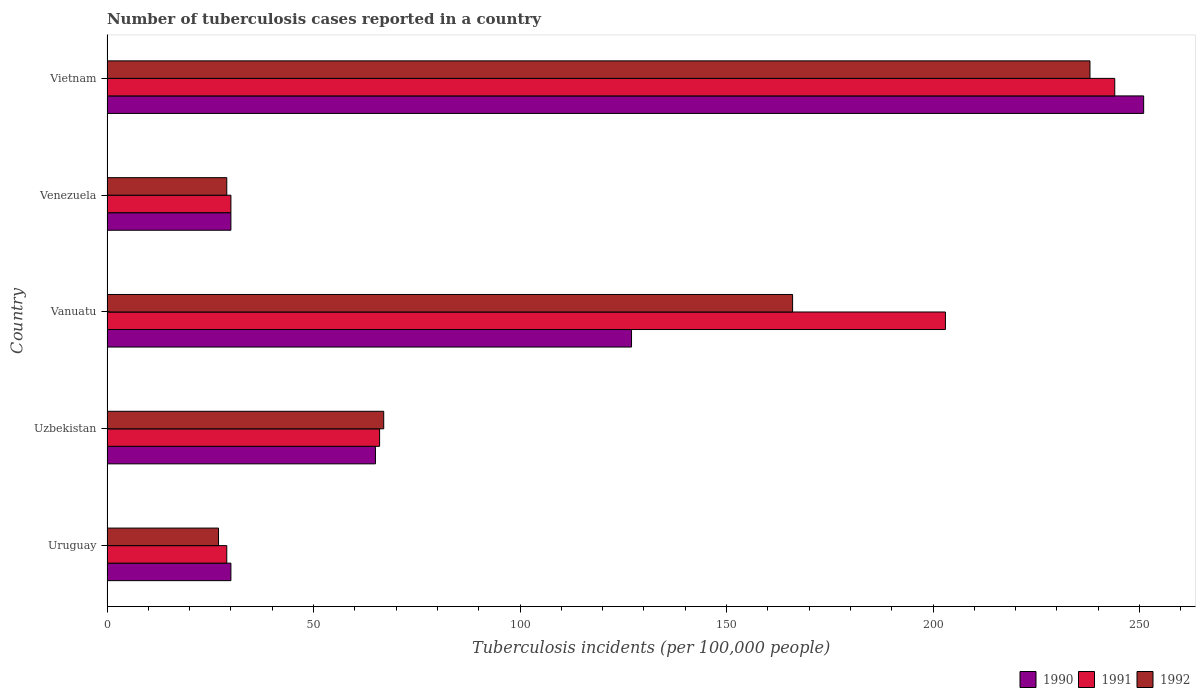How many different coloured bars are there?
Keep it short and to the point. 3. How many groups of bars are there?
Keep it short and to the point. 5. Are the number of bars per tick equal to the number of legend labels?
Offer a very short reply. Yes. Are the number of bars on each tick of the Y-axis equal?
Offer a terse response. Yes. How many bars are there on the 1st tick from the bottom?
Provide a succinct answer. 3. What is the label of the 5th group of bars from the top?
Your response must be concise. Uruguay. What is the number of tuberculosis cases reported in in 1992 in Vietnam?
Offer a terse response. 238. Across all countries, what is the maximum number of tuberculosis cases reported in in 1990?
Make the answer very short. 251. Across all countries, what is the minimum number of tuberculosis cases reported in in 1991?
Offer a terse response. 29. In which country was the number of tuberculosis cases reported in in 1990 maximum?
Give a very brief answer. Vietnam. In which country was the number of tuberculosis cases reported in in 1991 minimum?
Your answer should be very brief. Uruguay. What is the total number of tuberculosis cases reported in in 1991 in the graph?
Provide a succinct answer. 572. What is the difference between the number of tuberculosis cases reported in in 1991 in Uzbekistan and that in Vietnam?
Your answer should be compact. -178. What is the difference between the number of tuberculosis cases reported in in 1991 in Venezuela and the number of tuberculosis cases reported in in 1990 in Vanuatu?
Offer a very short reply. -97. What is the average number of tuberculosis cases reported in in 1991 per country?
Your response must be concise. 114.4. What is the ratio of the number of tuberculosis cases reported in in 1992 in Uzbekistan to that in Vanuatu?
Your answer should be very brief. 0.4. Is the number of tuberculosis cases reported in in 1992 in Uzbekistan less than that in Vietnam?
Offer a terse response. Yes. What is the difference between the highest and the second highest number of tuberculosis cases reported in in 1992?
Offer a terse response. 72. What is the difference between the highest and the lowest number of tuberculosis cases reported in in 1991?
Your response must be concise. 215. What does the 1st bar from the top in Vanuatu represents?
Ensure brevity in your answer.  1992. What does the 2nd bar from the bottom in Vietnam represents?
Ensure brevity in your answer.  1991. How many bars are there?
Ensure brevity in your answer.  15. Are all the bars in the graph horizontal?
Make the answer very short. Yes. What is the difference between two consecutive major ticks on the X-axis?
Provide a succinct answer. 50. Does the graph contain grids?
Provide a short and direct response. No. How many legend labels are there?
Keep it short and to the point. 3. How are the legend labels stacked?
Your answer should be very brief. Horizontal. What is the title of the graph?
Your answer should be compact. Number of tuberculosis cases reported in a country. Does "1999" appear as one of the legend labels in the graph?
Ensure brevity in your answer.  No. What is the label or title of the X-axis?
Your answer should be compact. Tuberculosis incidents (per 100,0 people). What is the label or title of the Y-axis?
Provide a succinct answer. Country. What is the Tuberculosis incidents (per 100,000 people) of 1991 in Uruguay?
Your answer should be very brief. 29. What is the Tuberculosis incidents (per 100,000 people) of 1992 in Uruguay?
Provide a succinct answer. 27. What is the Tuberculosis incidents (per 100,000 people) in 1991 in Uzbekistan?
Offer a terse response. 66. What is the Tuberculosis incidents (per 100,000 people) in 1990 in Vanuatu?
Give a very brief answer. 127. What is the Tuberculosis incidents (per 100,000 people) of 1991 in Vanuatu?
Provide a succinct answer. 203. What is the Tuberculosis incidents (per 100,000 people) of 1992 in Vanuatu?
Ensure brevity in your answer.  166. What is the Tuberculosis incidents (per 100,000 people) in 1991 in Venezuela?
Keep it short and to the point. 30. What is the Tuberculosis incidents (per 100,000 people) of 1990 in Vietnam?
Offer a very short reply. 251. What is the Tuberculosis incidents (per 100,000 people) of 1991 in Vietnam?
Keep it short and to the point. 244. What is the Tuberculosis incidents (per 100,000 people) in 1992 in Vietnam?
Provide a succinct answer. 238. Across all countries, what is the maximum Tuberculosis incidents (per 100,000 people) of 1990?
Provide a short and direct response. 251. Across all countries, what is the maximum Tuberculosis incidents (per 100,000 people) of 1991?
Provide a succinct answer. 244. Across all countries, what is the maximum Tuberculosis incidents (per 100,000 people) of 1992?
Keep it short and to the point. 238. Across all countries, what is the minimum Tuberculosis incidents (per 100,000 people) of 1990?
Make the answer very short. 30. Across all countries, what is the minimum Tuberculosis incidents (per 100,000 people) in 1991?
Ensure brevity in your answer.  29. What is the total Tuberculosis incidents (per 100,000 people) in 1990 in the graph?
Provide a short and direct response. 503. What is the total Tuberculosis incidents (per 100,000 people) of 1991 in the graph?
Provide a short and direct response. 572. What is the total Tuberculosis incidents (per 100,000 people) of 1992 in the graph?
Offer a very short reply. 527. What is the difference between the Tuberculosis incidents (per 100,000 people) of 1990 in Uruguay and that in Uzbekistan?
Your response must be concise. -35. What is the difference between the Tuberculosis incidents (per 100,000 people) of 1991 in Uruguay and that in Uzbekistan?
Make the answer very short. -37. What is the difference between the Tuberculosis incidents (per 100,000 people) of 1990 in Uruguay and that in Vanuatu?
Keep it short and to the point. -97. What is the difference between the Tuberculosis incidents (per 100,000 people) in 1991 in Uruguay and that in Vanuatu?
Offer a very short reply. -174. What is the difference between the Tuberculosis incidents (per 100,000 people) in 1992 in Uruguay and that in Vanuatu?
Keep it short and to the point. -139. What is the difference between the Tuberculosis incidents (per 100,000 people) in 1990 in Uruguay and that in Venezuela?
Your answer should be compact. 0. What is the difference between the Tuberculosis incidents (per 100,000 people) in 1991 in Uruguay and that in Venezuela?
Your answer should be very brief. -1. What is the difference between the Tuberculosis incidents (per 100,000 people) in 1992 in Uruguay and that in Venezuela?
Provide a succinct answer. -2. What is the difference between the Tuberculosis incidents (per 100,000 people) in 1990 in Uruguay and that in Vietnam?
Provide a succinct answer. -221. What is the difference between the Tuberculosis incidents (per 100,000 people) of 1991 in Uruguay and that in Vietnam?
Make the answer very short. -215. What is the difference between the Tuberculosis incidents (per 100,000 people) of 1992 in Uruguay and that in Vietnam?
Provide a short and direct response. -211. What is the difference between the Tuberculosis incidents (per 100,000 people) in 1990 in Uzbekistan and that in Vanuatu?
Ensure brevity in your answer.  -62. What is the difference between the Tuberculosis incidents (per 100,000 people) in 1991 in Uzbekistan and that in Vanuatu?
Make the answer very short. -137. What is the difference between the Tuberculosis incidents (per 100,000 people) of 1992 in Uzbekistan and that in Vanuatu?
Provide a short and direct response. -99. What is the difference between the Tuberculosis incidents (per 100,000 people) of 1990 in Uzbekistan and that in Vietnam?
Provide a succinct answer. -186. What is the difference between the Tuberculosis incidents (per 100,000 people) of 1991 in Uzbekistan and that in Vietnam?
Your answer should be very brief. -178. What is the difference between the Tuberculosis incidents (per 100,000 people) in 1992 in Uzbekistan and that in Vietnam?
Ensure brevity in your answer.  -171. What is the difference between the Tuberculosis incidents (per 100,000 people) of 1990 in Vanuatu and that in Venezuela?
Offer a very short reply. 97. What is the difference between the Tuberculosis incidents (per 100,000 people) of 1991 in Vanuatu and that in Venezuela?
Provide a succinct answer. 173. What is the difference between the Tuberculosis incidents (per 100,000 people) in 1992 in Vanuatu and that in Venezuela?
Give a very brief answer. 137. What is the difference between the Tuberculosis incidents (per 100,000 people) of 1990 in Vanuatu and that in Vietnam?
Provide a succinct answer. -124. What is the difference between the Tuberculosis incidents (per 100,000 people) of 1991 in Vanuatu and that in Vietnam?
Your answer should be compact. -41. What is the difference between the Tuberculosis incidents (per 100,000 people) of 1992 in Vanuatu and that in Vietnam?
Offer a terse response. -72. What is the difference between the Tuberculosis incidents (per 100,000 people) of 1990 in Venezuela and that in Vietnam?
Make the answer very short. -221. What is the difference between the Tuberculosis incidents (per 100,000 people) of 1991 in Venezuela and that in Vietnam?
Provide a short and direct response. -214. What is the difference between the Tuberculosis incidents (per 100,000 people) in 1992 in Venezuela and that in Vietnam?
Keep it short and to the point. -209. What is the difference between the Tuberculosis incidents (per 100,000 people) of 1990 in Uruguay and the Tuberculosis incidents (per 100,000 people) of 1991 in Uzbekistan?
Provide a short and direct response. -36. What is the difference between the Tuberculosis incidents (per 100,000 people) in 1990 in Uruguay and the Tuberculosis incidents (per 100,000 people) in 1992 in Uzbekistan?
Your answer should be very brief. -37. What is the difference between the Tuberculosis incidents (per 100,000 people) of 1991 in Uruguay and the Tuberculosis incidents (per 100,000 people) of 1992 in Uzbekistan?
Offer a very short reply. -38. What is the difference between the Tuberculosis incidents (per 100,000 people) of 1990 in Uruguay and the Tuberculosis incidents (per 100,000 people) of 1991 in Vanuatu?
Your response must be concise. -173. What is the difference between the Tuberculosis incidents (per 100,000 people) in 1990 in Uruguay and the Tuberculosis incidents (per 100,000 people) in 1992 in Vanuatu?
Your answer should be very brief. -136. What is the difference between the Tuberculosis incidents (per 100,000 people) of 1991 in Uruguay and the Tuberculosis incidents (per 100,000 people) of 1992 in Vanuatu?
Keep it short and to the point. -137. What is the difference between the Tuberculosis incidents (per 100,000 people) of 1990 in Uruguay and the Tuberculosis incidents (per 100,000 people) of 1991 in Venezuela?
Give a very brief answer. 0. What is the difference between the Tuberculosis incidents (per 100,000 people) in 1990 in Uruguay and the Tuberculosis incidents (per 100,000 people) in 1992 in Venezuela?
Offer a terse response. 1. What is the difference between the Tuberculosis incidents (per 100,000 people) in 1990 in Uruguay and the Tuberculosis incidents (per 100,000 people) in 1991 in Vietnam?
Give a very brief answer. -214. What is the difference between the Tuberculosis incidents (per 100,000 people) in 1990 in Uruguay and the Tuberculosis incidents (per 100,000 people) in 1992 in Vietnam?
Give a very brief answer. -208. What is the difference between the Tuberculosis incidents (per 100,000 people) in 1991 in Uruguay and the Tuberculosis incidents (per 100,000 people) in 1992 in Vietnam?
Provide a short and direct response. -209. What is the difference between the Tuberculosis incidents (per 100,000 people) of 1990 in Uzbekistan and the Tuberculosis incidents (per 100,000 people) of 1991 in Vanuatu?
Provide a succinct answer. -138. What is the difference between the Tuberculosis incidents (per 100,000 people) of 1990 in Uzbekistan and the Tuberculosis incidents (per 100,000 people) of 1992 in Vanuatu?
Make the answer very short. -101. What is the difference between the Tuberculosis incidents (per 100,000 people) of 1991 in Uzbekistan and the Tuberculosis incidents (per 100,000 people) of 1992 in Vanuatu?
Offer a very short reply. -100. What is the difference between the Tuberculosis incidents (per 100,000 people) of 1990 in Uzbekistan and the Tuberculosis incidents (per 100,000 people) of 1992 in Venezuela?
Keep it short and to the point. 36. What is the difference between the Tuberculosis incidents (per 100,000 people) of 1991 in Uzbekistan and the Tuberculosis incidents (per 100,000 people) of 1992 in Venezuela?
Your answer should be very brief. 37. What is the difference between the Tuberculosis incidents (per 100,000 people) of 1990 in Uzbekistan and the Tuberculosis incidents (per 100,000 people) of 1991 in Vietnam?
Ensure brevity in your answer.  -179. What is the difference between the Tuberculosis incidents (per 100,000 people) in 1990 in Uzbekistan and the Tuberculosis incidents (per 100,000 people) in 1992 in Vietnam?
Your answer should be very brief. -173. What is the difference between the Tuberculosis incidents (per 100,000 people) of 1991 in Uzbekistan and the Tuberculosis incidents (per 100,000 people) of 1992 in Vietnam?
Give a very brief answer. -172. What is the difference between the Tuberculosis incidents (per 100,000 people) of 1990 in Vanuatu and the Tuberculosis incidents (per 100,000 people) of 1991 in Venezuela?
Your response must be concise. 97. What is the difference between the Tuberculosis incidents (per 100,000 people) in 1990 in Vanuatu and the Tuberculosis incidents (per 100,000 people) in 1992 in Venezuela?
Offer a very short reply. 98. What is the difference between the Tuberculosis incidents (per 100,000 people) in 1991 in Vanuatu and the Tuberculosis incidents (per 100,000 people) in 1992 in Venezuela?
Give a very brief answer. 174. What is the difference between the Tuberculosis incidents (per 100,000 people) of 1990 in Vanuatu and the Tuberculosis incidents (per 100,000 people) of 1991 in Vietnam?
Make the answer very short. -117. What is the difference between the Tuberculosis incidents (per 100,000 people) in 1990 in Vanuatu and the Tuberculosis incidents (per 100,000 people) in 1992 in Vietnam?
Provide a succinct answer. -111. What is the difference between the Tuberculosis incidents (per 100,000 people) in 1991 in Vanuatu and the Tuberculosis incidents (per 100,000 people) in 1992 in Vietnam?
Offer a very short reply. -35. What is the difference between the Tuberculosis incidents (per 100,000 people) in 1990 in Venezuela and the Tuberculosis incidents (per 100,000 people) in 1991 in Vietnam?
Provide a succinct answer. -214. What is the difference between the Tuberculosis incidents (per 100,000 people) of 1990 in Venezuela and the Tuberculosis incidents (per 100,000 people) of 1992 in Vietnam?
Make the answer very short. -208. What is the difference between the Tuberculosis incidents (per 100,000 people) in 1991 in Venezuela and the Tuberculosis incidents (per 100,000 people) in 1992 in Vietnam?
Keep it short and to the point. -208. What is the average Tuberculosis incidents (per 100,000 people) in 1990 per country?
Provide a short and direct response. 100.6. What is the average Tuberculosis incidents (per 100,000 people) in 1991 per country?
Keep it short and to the point. 114.4. What is the average Tuberculosis incidents (per 100,000 people) in 1992 per country?
Provide a succinct answer. 105.4. What is the difference between the Tuberculosis incidents (per 100,000 people) in 1990 and Tuberculosis incidents (per 100,000 people) in 1991 in Uruguay?
Offer a terse response. 1. What is the difference between the Tuberculosis incidents (per 100,000 people) in 1990 and Tuberculosis incidents (per 100,000 people) in 1992 in Uzbekistan?
Keep it short and to the point. -2. What is the difference between the Tuberculosis incidents (per 100,000 people) of 1991 and Tuberculosis incidents (per 100,000 people) of 1992 in Uzbekistan?
Keep it short and to the point. -1. What is the difference between the Tuberculosis incidents (per 100,000 people) in 1990 and Tuberculosis incidents (per 100,000 people) in 1991 in Vanuatu?
Your answer should be compact. -76. What is the difference between the Tuberculosis incidents (per 100,000 people) of 1990 and Tuberculosis incidents (per 100,000 people) of 1992 in Vanuatu?
Give a very brief answer. -39. What is the difference between the Tuberculosis incidents (per 100,000 people) of 1990 and Tuberculosis incidents (per 100,000 people) of 1991 in Venezuela?
Keep it short and to the point. 0. What is the difference between the Tuberculosis incidents (per 100,000 people) of 1990 and Tuberculosis incidents (per 100,000 people) of 1992 in Venezuela?
Provide a short and direct response. 1. What is the difference between the Tuberculosis incidents (per 100,000 people) of 1991 and Tuberculosis incidents (per 100,000 people) of 1992 in Venezuela?
Make the answer very short. 1. What is the difference between the Tuberculosis incidents (per 100,000 people) in 1990 and Tuberculosis incidents (per 100,000 people) in 1991 in Vietnam?
Make the answer very short. 7. What is the difference between the Tuberculosis incidents (per 100,000 people) in 1991 and Tuberculosis incidents (per 100,000 people) in 1992 in Vietnam?
Ensure brevity in your answer.  6. What is the ratio of the Tuberculosis incidents (per 100,000 people) in 1990 in Uruguay to that in Uzbekistan?
Keep it short and to the point. 0.46. What is the ratio of the Tuberculosis incidents (per 100,000 people) of 1991 in Uruguay to that in Uzbekistan?
Your answer should be compact. 0.44. What is the ratio of the Tuberculosis incidents (per 100,000 people) in 1992 in Uruguay to that in Uzbekistan?
Provide a short and direct response. 0.4. What is the ratio of the Tuberculosis incidents (per 100,000 people) in 1990 in Uruguay to that in Vanuatu?
Your answer should be very brief. 0.24. What is the ratio of the Tuberculosis incidents (per 100,000 people) in 1991 in Uruguay to that in Vanuatu?
Offer a very short reply. 0.14. What is the ratio of the Tuberculosis incidents (per 100,000 people) in 1992 in Uruguay to that in Vanuatu?
Give a very brief answer. 0.16. What is the ratio of the Tuberculosis incidents (per 100,000 people) in 1990 in Uruguay to that in Venezuela?
Offer a terse response. 1. What is the ratio of the Tuberculosis incidents (per 100,000 people) of 1991 in Uruguay to that in Venezuela?
Keep it short and to the point. 0.97. What is the ratio of the Tuberculosis incidents (per 100,000 people) in 1992 in Uruguay to that in Venezuela?
Offer a very short reply. 0.93. What is the ratio of the Tuberculosis incidents (per 100,000 people) in 1990 in Uruguay to that in Vietnam?
Offer a very short reply. 0.12. What is the ratio of the Tuberculosis incidents (per 100,000 people) in 1991 in Uruguay to that in Vietnam?
Provide a succinct answer. 0.12. What is the ratio of the Tuberculosis incidents (per 100,000 people) of 1992 in Uruguay to that in Vietnam?
Keep it short and to the point. 0.11. What is the ratio of the Tuberculosis incidents (per 100,000 people) of 1990 in Uzbekistan to that in Vanuatu?
Provide a succinct answer. 0.51. What is the ratio of the Tuberculosis incidents (per 100,000 people) in 1991 in Uzbekistan to that in Vanuatu?
Keep it short and to the point. 0.33. What is the ratio of the Tuberculosis incidents (per 100,000 people) of 1992 in Uzbekistan to that in Vanuatu?
Your answer should be very brief. 0.4. What is the ratio of the Tuberculosis incidents (per 100,000 people) of 1990 in Uzbekistan to that in Venezuela?
Make the answer very short. 2.17. What is the ratio of the Tuberculosis incidents (per 100,000 people) of 1991 in Uzbekistan to that in Venezuela?
Provide a short and direct response. 2.2. What is the ratio of the Tuberculosis incidents (per 100,000 people) in 1992 in Uzbekistan to that in Venezuela?
Keep it short and to the point. 2.31. What is the ratio of the Tuberculosis incidents (per 100,000 people) of 1990 in Uzbekistan to that in Vietnam?
Your answer should be compact. 0.26. What is the ratio of the Tuberculosis incidents (per 100,000 people) of 1991 in Uzbekistan to that in Vietnam?
Your response must be concise. 0.27. What is the ratio of the Tuberculosis incidents (per 100,000 people) of 1992 in Uzbekistan to that in Vietnam?
Give a very brief answer. 0.28. What is the ratio of the Tuberculosis incidents (per 100,000 people) of 1990 in Vanuatu to that in Venezuela?
Keep it short and to the point. 4.23. What is the ratio of the Tuberculosis incidents (per 100,000 people) of 1991 in Vanuatu to that in Venezuela?
Offer a terse response. 6.77. What is the ratio of the Tuberculosis incidents (per 100,000 people) of 1992 in Vanuatu to that in Venezuela?
Ensure brevity in your answer.  5.72. What is the ratio of the Tuberculosis incidents (per 100,000 people) of 1990 in Vanuatu to that in Vietnam?
Make the answer very short. 0.51. What is the ratio of the Tuberculosis incidents (per 100,000 people) in 1991 in Vanuatu to that in Vietnam?
Give a very brief answer. 0.83. What is the ratio of the Tuberculosis incidents (per 100,000 people) of 1992 in Vanuatu to that in Vietnam?
Provide a succinct answer. 0.7. What is the ratio of the Tuberculosis incidents (per 100,000 people) in 1990 in Venezuela to that in Vietnam?
Ensure brevity in your answer.  0.12. What is the ratio of the Tuberculosis incidents (per 100,000 people) of 1991 in Venezuela to that in Vietnam?
Provide a succinct answer. 0.12. What is the ratio of the Tuberculosis incidents (per 100,000 people) in 1992 in Venezuela to that in Vietnam?
Your answer should be very brief. 0.12. What is the difference between the highest and the second highest Tuberculosis incidents (per 100,000 people) in 1990?
Offer a very short reply. 124. What is the difference between the highest and the second highest Tuberculosis incidents (per 100,000 people) in 1991?
Your answer should be very brief. 41. What is the difference between the highest and the second highest Tuberculosis incidents (per 100,000 people) in 1992?
Keep it short and to the point. 72. What is the difference between the highest and the lowest Tuberculosis incidents (per 100,000 people) in 1990?
Your answer should be compact. 221. What is the difference between the highest and the lowest Tuberculosis incidents (per 100,000 people) in 1991?
Your answer should be compact. 215. What is the difference between the highest and the lowest Tuberculosis incidents (per 100,000 people) of 1992?
Keep it short and to the point. 211. 